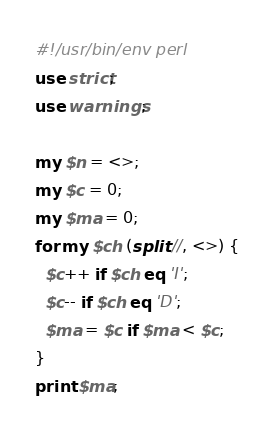Convert code to text. <code><loc_0><loc_0><loc_500><loc_500><_Perl_>#!/usr/bin/env perl
use strict;
use warnings;

my $n = <>;
my $c = 0;
my $ma = 0;
for my $ch (split //, <>) {
  $c++ if $ch eq 'I';
  $c-- if $ch eq 'D';
  $ma = $c if $ma < $c;
}
print $ma;
</code> 